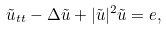<formula> <loc_0><loc_0><loc_500><loc_500>\tilde { u } _ { t t } - \Delta \tilde { u } + | \tilde { u } | ^ { 2 } \tilde { u } = e ,</formula> 